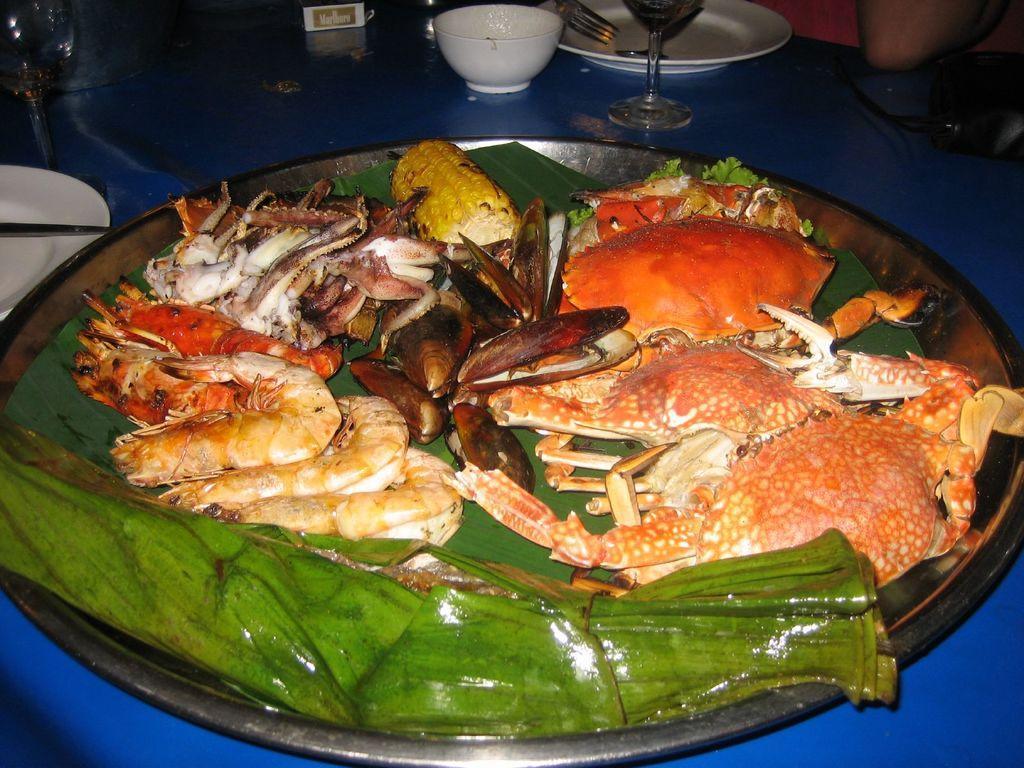Please provide a concise description of this image. In this picture I can see food items on the leaf ,on the plate, there is a bowl ,plates, fork, glasses and some items on the table, and in the background there is a person. 